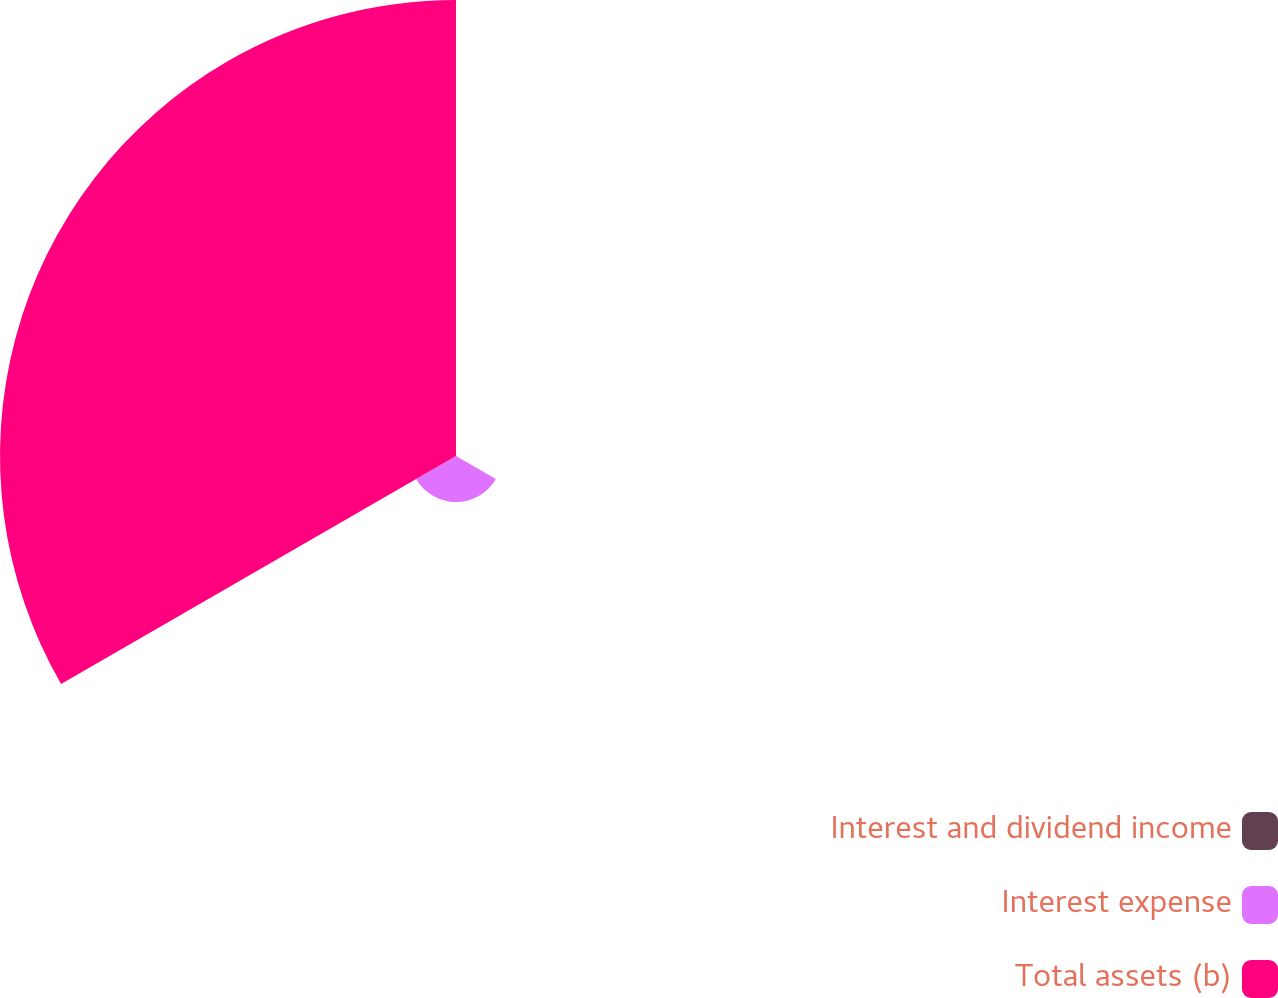Convert chart. <chart><loc_0><loc_0><loc_500><loc_500><pie_chart><fcel>Interest and dividend income<fcel>Interest expense<fcel>Total assets (b)<nl><fcel>0.09%<fcel>9.16%<fcel>90.76%<nl></chart> 